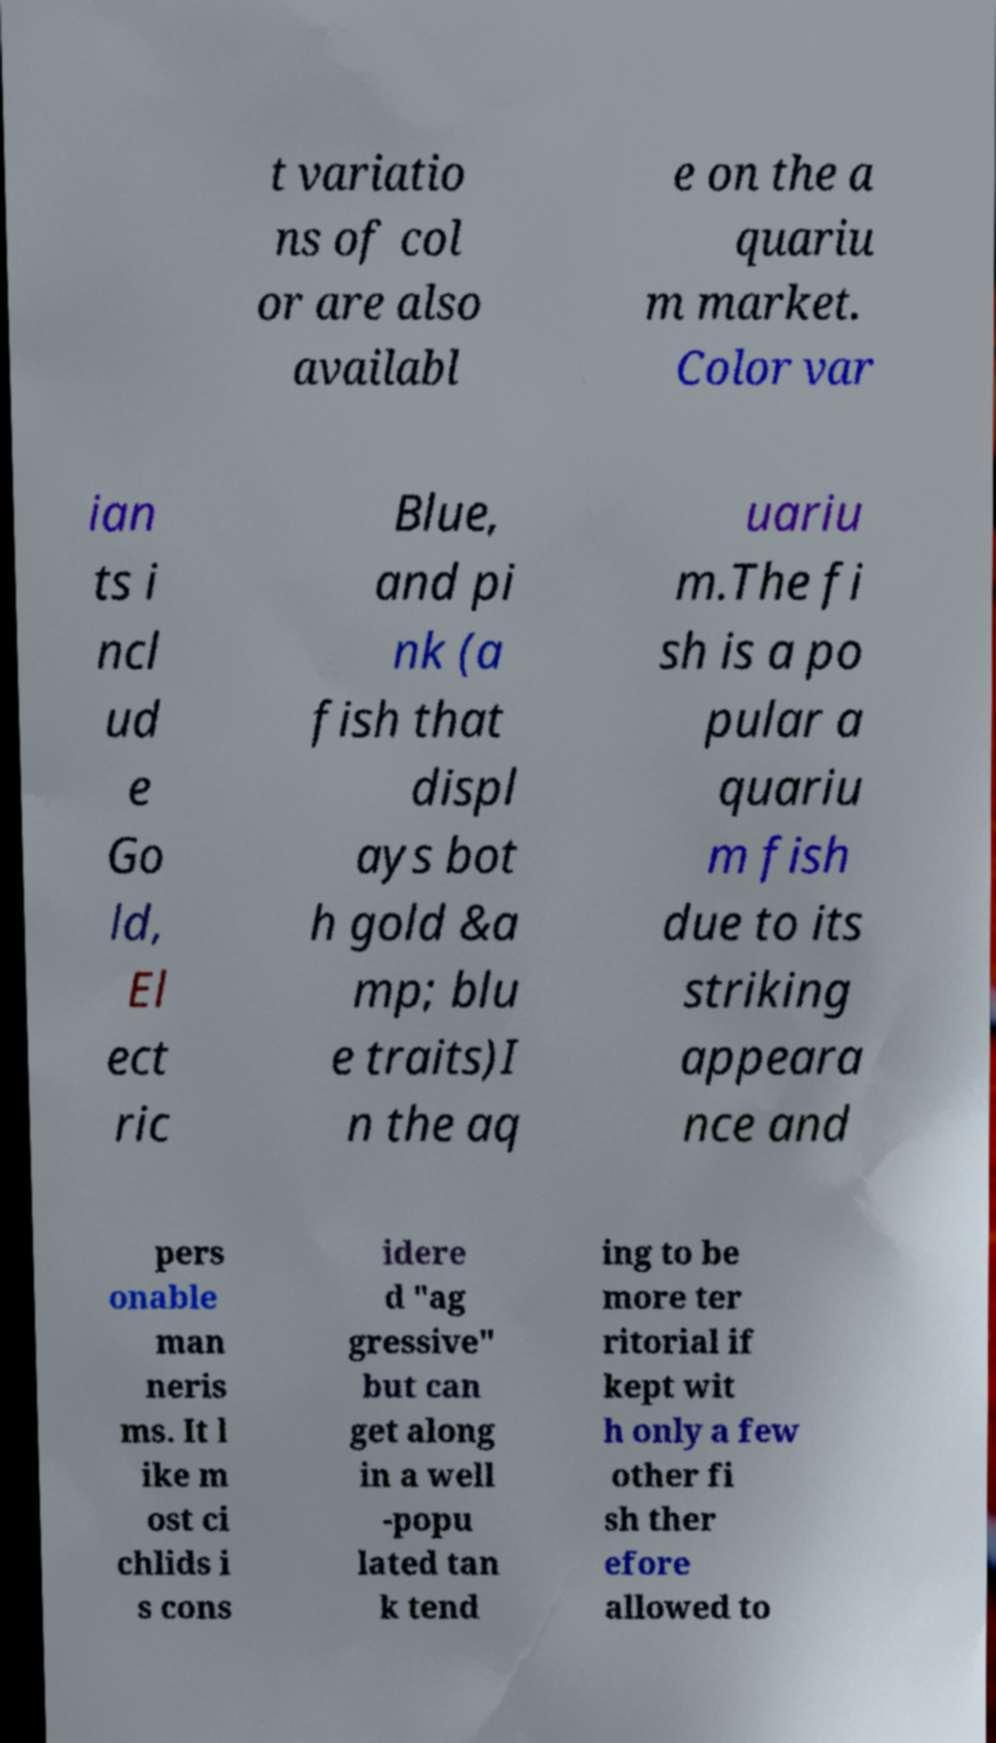Please identify and transcribe the text found in this image. t variatio ns of col or are also availabl e on the a quariu m market. Color var ian ts i ncl ud e Go ld, El ect ric Blue, and pi nk (a fish that displ ays bot h gold &a mp; blu e traits)I n the aq uariu m.The fi sh is a po pular a quariu m fish due to its striking appeara nce and pers onable man neris ms. It l ike m ost ci chlids i s cons idere d "ag gressive" but can get along in a well -popu lated tan k tend ing to be more ter ritorial if kept wit h only a few other fi sh ther efore allowed to 